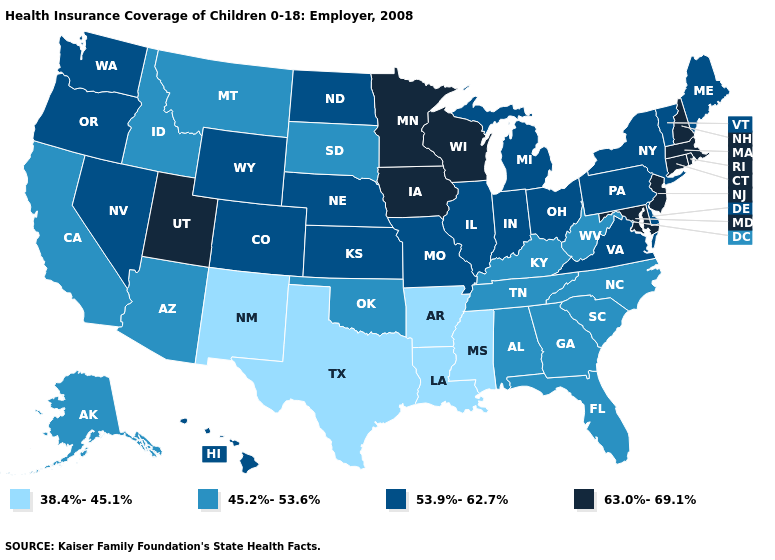Name the states that have a value in the range 63.0%-69.1%?
Short answer required. Connecticut, Iowa, Maryland, Massachusetts, Minnesota, New Hampshire, New Jersey, Rhode Island, Utah, Wisconsin. What is the value of Illinois?
Short answer required. 53.9%-62.7%. Does Colorado have a higher value than Tennessee?
Quick response, please. Yes. Name the states that have a value in the range 45.2%-53.6%?
Write a very short answer. Alabama, Alaska, Arizona, California, Florida, Georgia, Idaho, Kentucky, Montana, North Carolina, Oklahoma, South Carolina, South Dakota, Tennessee, West Virginia. What is the highest value in states that border Florida?
Answer briefly. 45.2%-53.6%. Does Louisiana have the lowest value in the USA?
Short answer required. Yes. Does the first symbol in the legend represent the smallest category?
Keep it brief. Yes. What is the value of Delaware?
Be succinct. 53.9%-62.7%. What is the lowest value in the USA?
Quick response, please. 38.4%-45.1%. Which states have the lowest value in the Northeast?
Short answer required. Maine, New York, Pennsylvania, Vermont. What is the value of Ohio?
Quick response, please. 53.9%-62.7%. Name the states that have a value in the range 53.9%-62.7%?
Write a very short answer. Colorado, Delaware, Hawaii, Illinois, Indiana, Kansas, Maine, Michigan, Missouri, Nebraska, Nevada, New York, North Dakota, Ohio, Oregon, Pennsylvania, Vermont, Virginia, Washington, Wyoming. Which states have the lowest value in the USA?
Give a very brief answer. Arkansas, Louisiana, Mississippi, New Mexico, Texas. What is the highest value in the Northeast ?
Write a very short answer. 63.0%-69.1%. Does Maryland have the highest value in the South?
Quick response, please. Yes. 